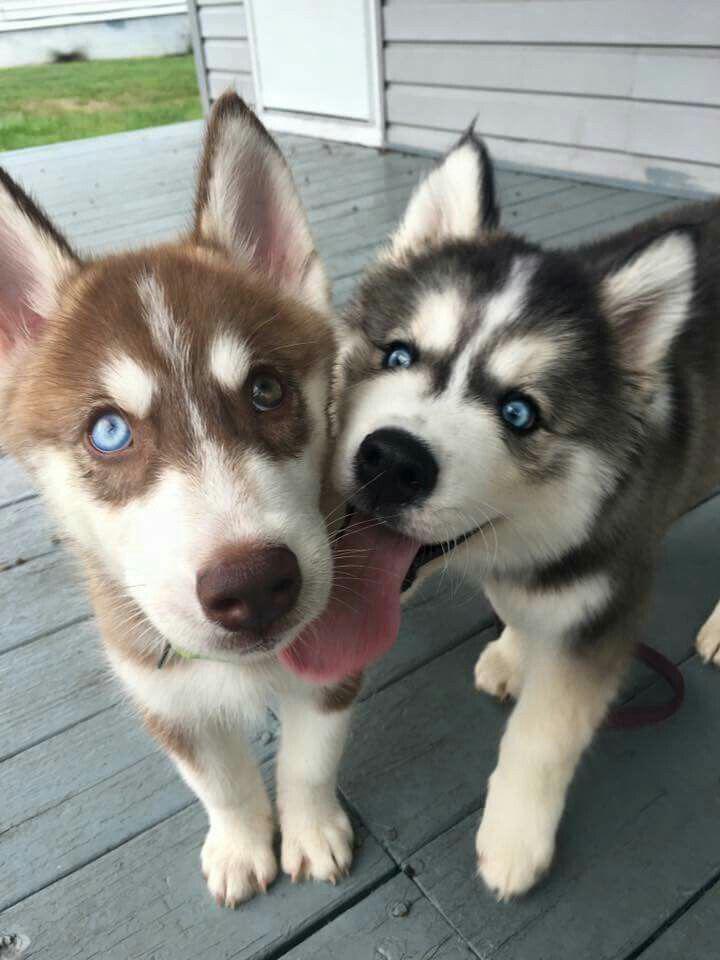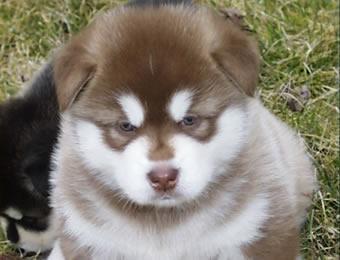The first image is the image on the left, the second image is the image on the right. Evaluate the accuracy of this statement regarding the images: "There are an equal number of dogs in each image.". Is it true? Answer yes or no. No. 